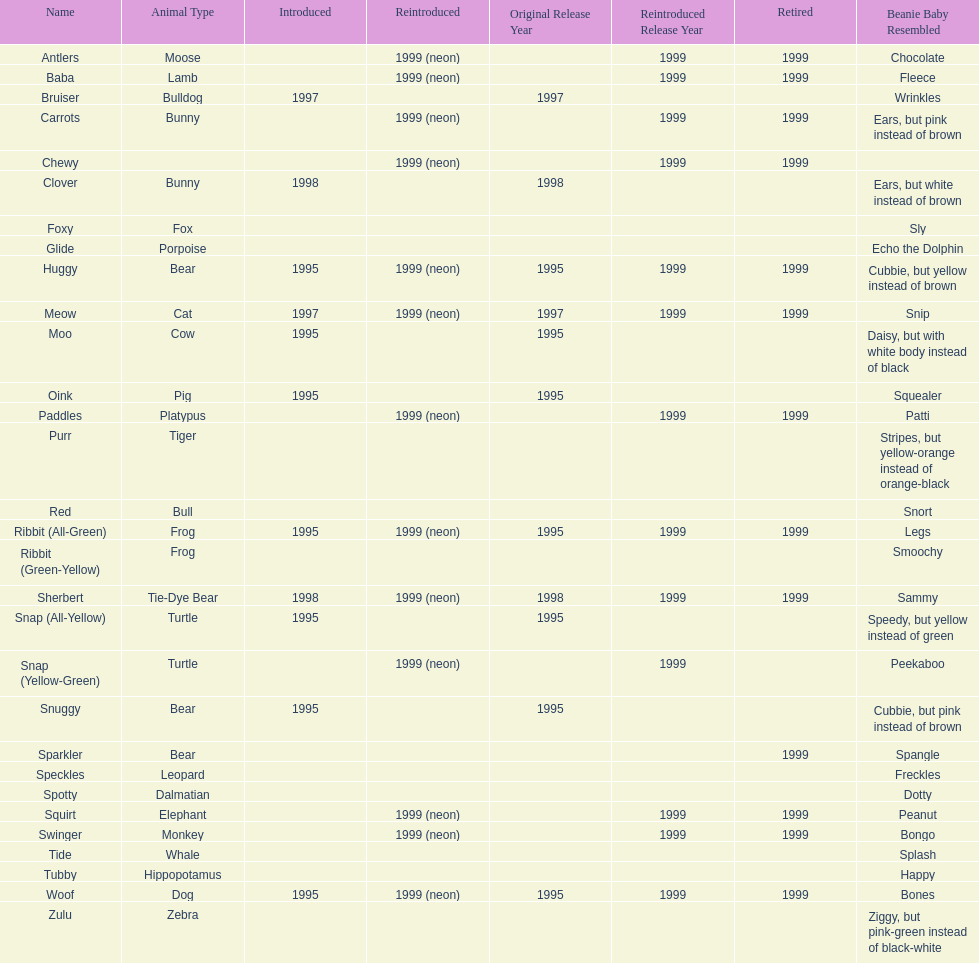What is the name of the last pillow pal on this chart? Zulu. 